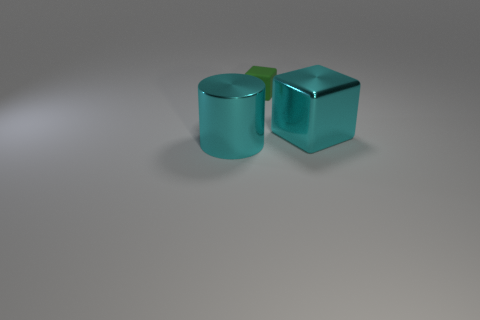What materials do the objects in the image appear to be made of? The objects in the image appear to be made of a glass-like material given their transparency and the way light interacts with their surfaces. 